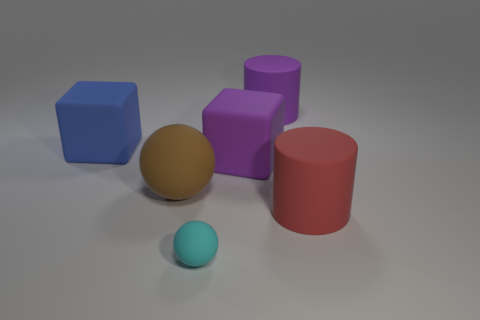Add 3 matte balls. How many objects exist? 9 Subtract all cylinders. How many objects are left? 4 Add 4 large blocks. How many large blocks are left? 6 Add 3 tiny blue matte cylinders. How many tiny blue matte cylinders exist? 3 Subtract 1 brown balls. How many objects are left? 5 Subtract all large yellow things. Subtract all blue matte blocks. How many objects are left? 5 